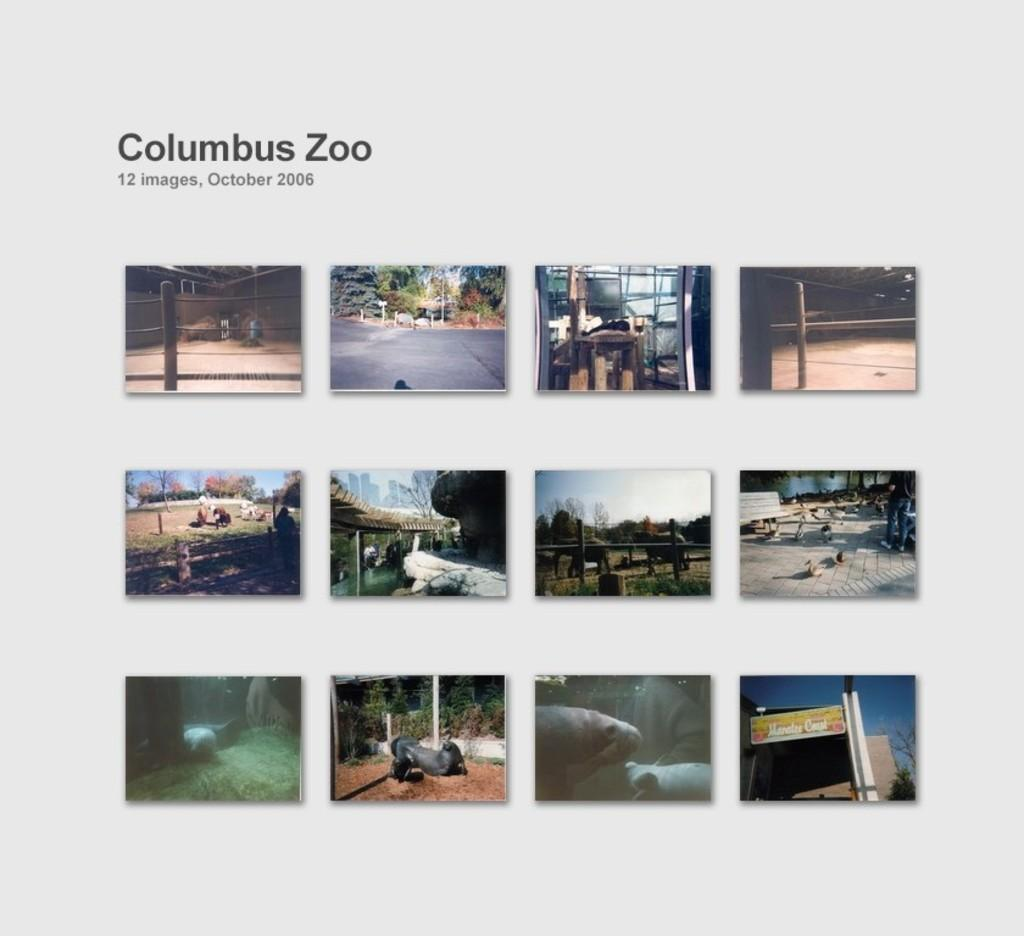What type of artwork is depicted in the image? The image is a collage. What can be found within the collage? The collage contains a group of images of different things. Is there any text present in the image? Yes, there is text present at the top of the collage. What type of tank is visible in the image? There is no tank present in the image; it is a collage containing various images and text. What type of agreement is being made in the image? There is no agreement being made in the image, as it is a collage of different images and text. 